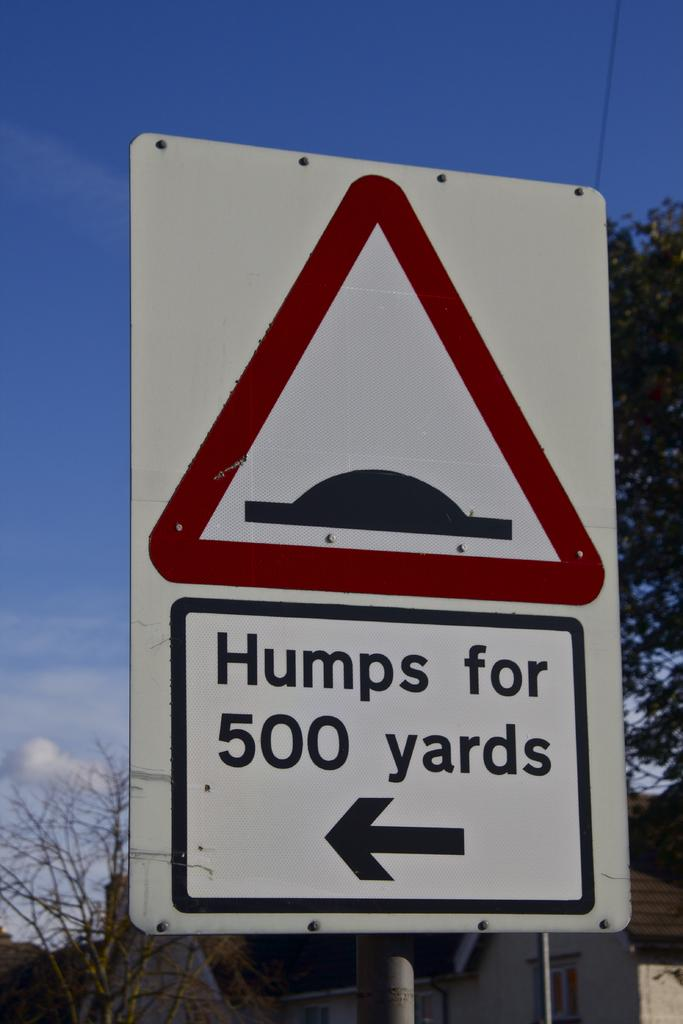<image>
Summarize the visual content of the image. A white street sign with a red triangle on it that says Humps for 500 yards on it. 